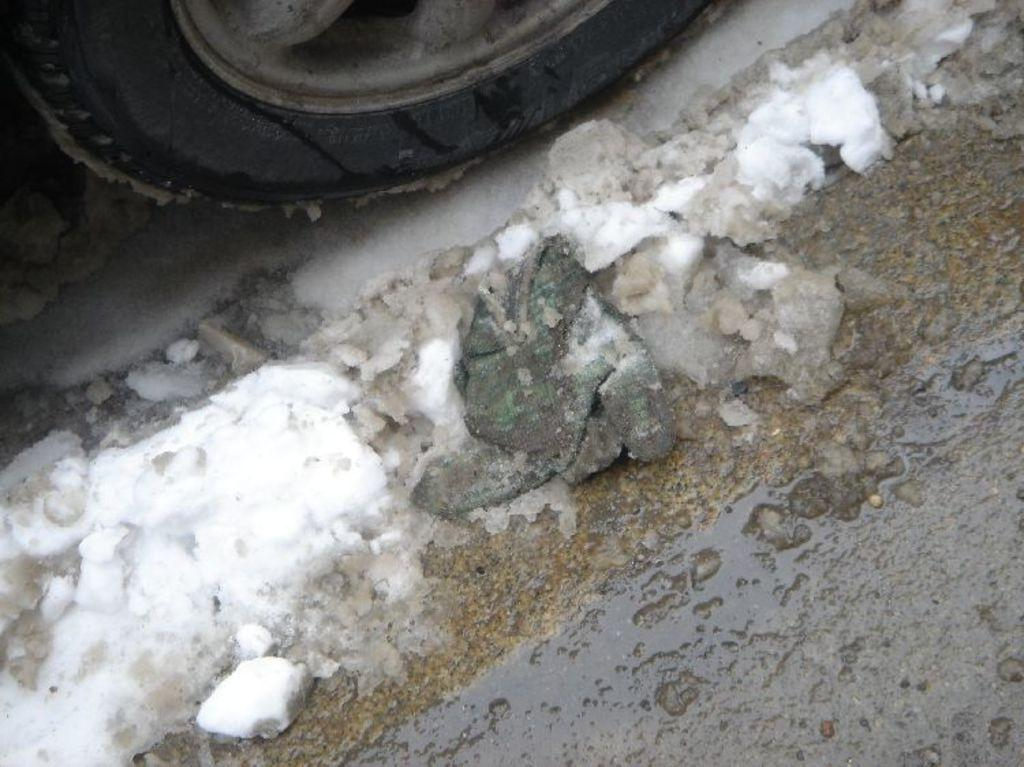What object is the main focus of the image? There is a vehicle tire in the image. What is the condition of the road in the image? There is snow on the road in the image. What religious symbol can be seen on the tire in the image? There is no religious symbol present on the tire in the image. How many planes are flying in the sky in the image? There are no planes visible in the image; it only features a vehicle tire and snow on the road. 